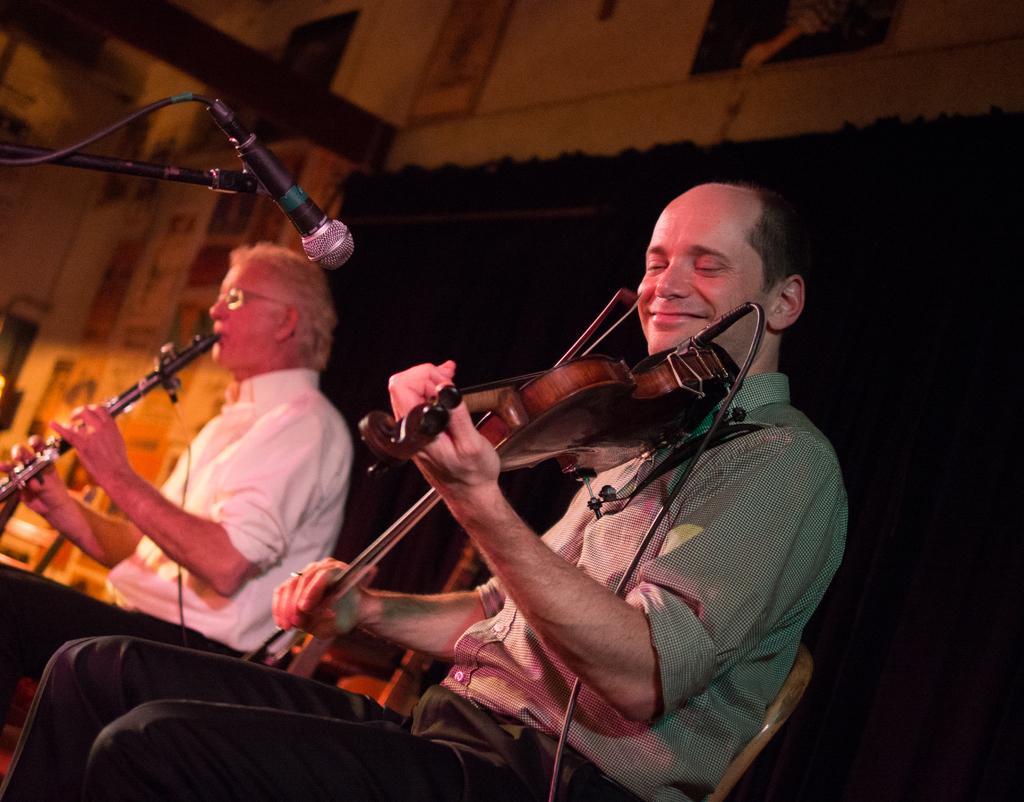Describe this image in one or two sentences. This is the image inside of the room. There are two persons in the image. There are with green shirt is sitting on the chair and he is playing violin and the person with white shirt is sitting and he is playing musical instrument and at the front there is a microphone and at the back there are frames on the wall. 